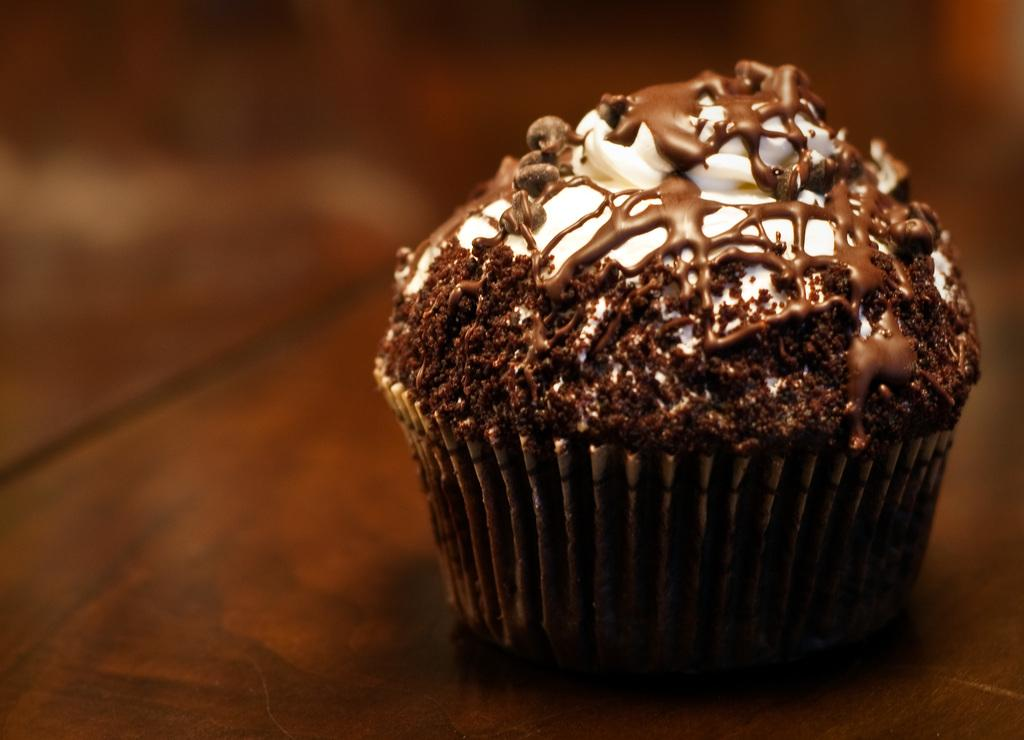What is the main subject of the image? There is a muffin in the image. Can you describe the setting of the image? There is a table in the background of the image. What type of volleyball is being played on the table in the image? There is no volleyball present in the image; it only features a muffin and a table in the background. 